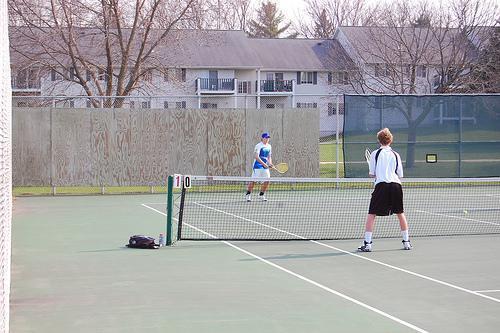How many people are in this photo?
Give a very brief answer. 2. How many people are playing tennis?
Give a very brief answer. 2. 